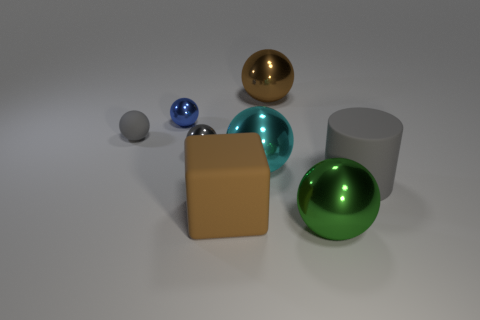Subtract all green balls. How many balls are left? 5 Subtract all big green spheres. How many spheres are left? 5 Subtract 1 spheres. How many spheres are left? 5 Subtract all red spheres. Subtract all gray cubes. How many spheres are left? 6 Add 2 green objects. How many objects exist? 10 Subtract all cylinders. How many objects are left? 7 Subtract all blocks. Subtract all small rubber balls. How many objects are left? 6 Add 8 large gray matte objects. How many large gray matte objects are left? 9 Add 1 tiny blue metallic spheres. How many tiny blue metallic spheres exist? 2 Subtract 1 cyan balls. How many objects are left? 7 